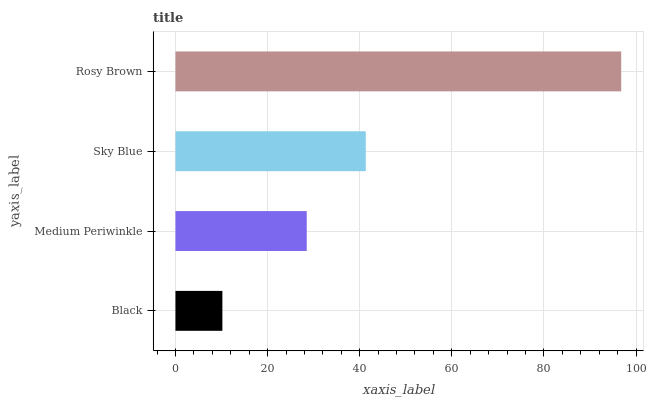Is Black the minimum?
Answer yes or no. Yes. Is Rosy Brown the maximum?
Answer yes or no. Yes. Is Medium Periwinkle the minimum?
Answer yes or no. No. Is Medium Periwinkle the maximum?
Answer yes or no. No. Is Medium Periwinkle greater than Black?
Answer yes or no. Yes. Is Black less than Medium Periwinkle?
Answer yes or no. Yes. Is Black greater than Medium Periwinkle?
Answer yes or no. No. Is Medium Periwinkle less than Black?
Answer yes or no. No. Is Sky Blue the high median?
Answer yes or no. Yes. Is Medium Periwinkle the low median?
Answer yes or no. Yes. Is Black the high median?
Answer yes or no. No. Is Rosy Brown the low median?
Answer yes or no. No. 